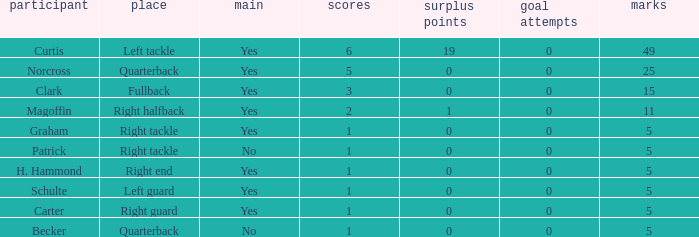Name the least touchdowns for 11 points 2.0. 